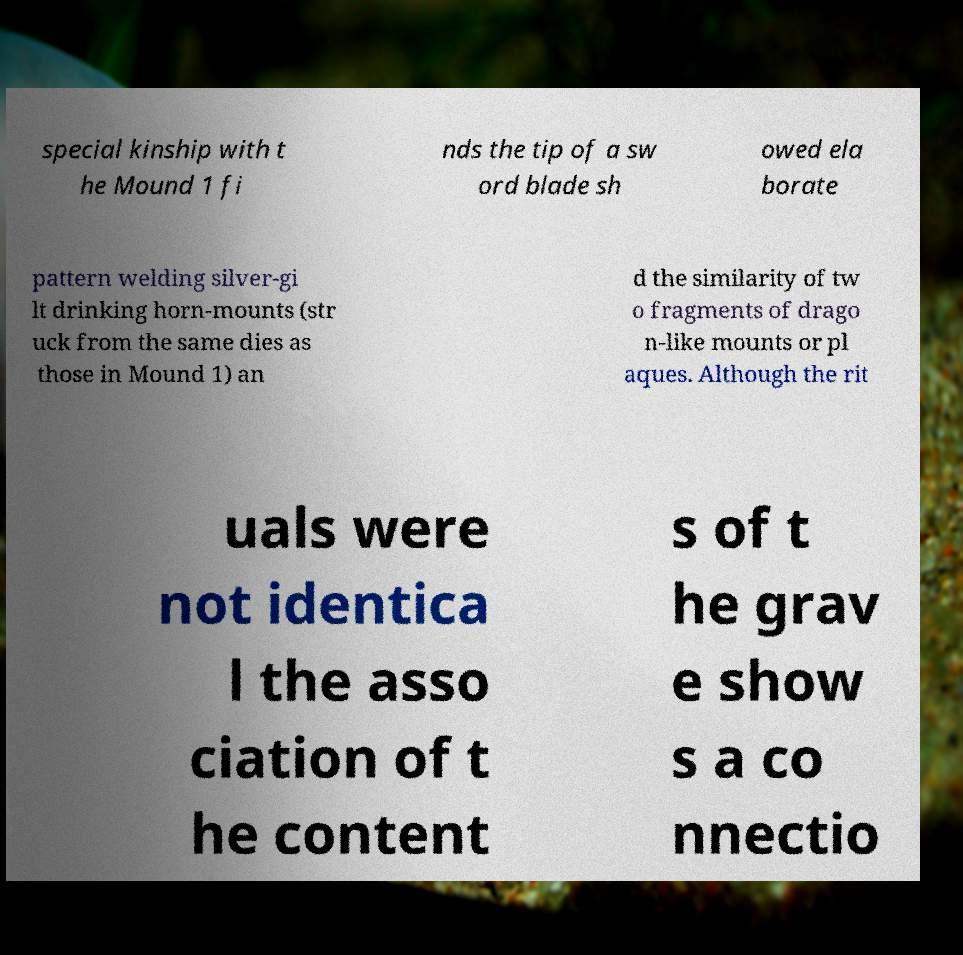Please identify and transcribe the text found in this image. special kinship with t he Mound 1 fi nds the tip of a sw ord blade sh owed ela borate pattern welding silver-gi lt drinking horn-mounts (str uck from the same dies as those in Mound 1) an d the similarity of tw o fragments of drago n-like mounts or pl aques. Although the rit uals were not identica l the asso ciation of t he content s of t he grav e show s a co nnectio 